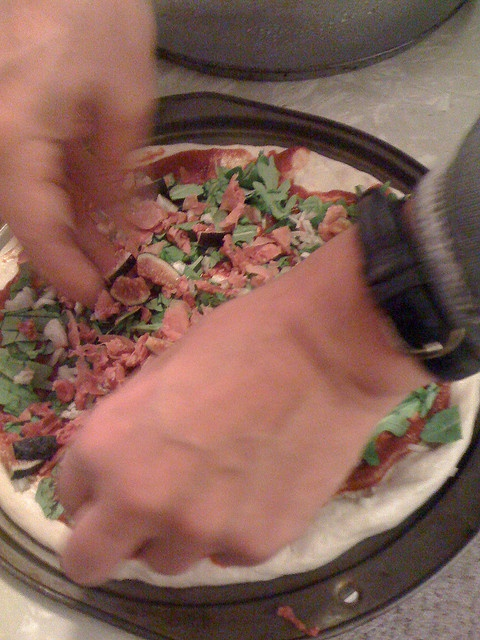Describe the objects in this image and their specific colors. I can see people in salmon and black tones, pizza in salmon, brown, maroon, gray, and olive tones, and people in salmon, brown, and maroon tones in this image. 